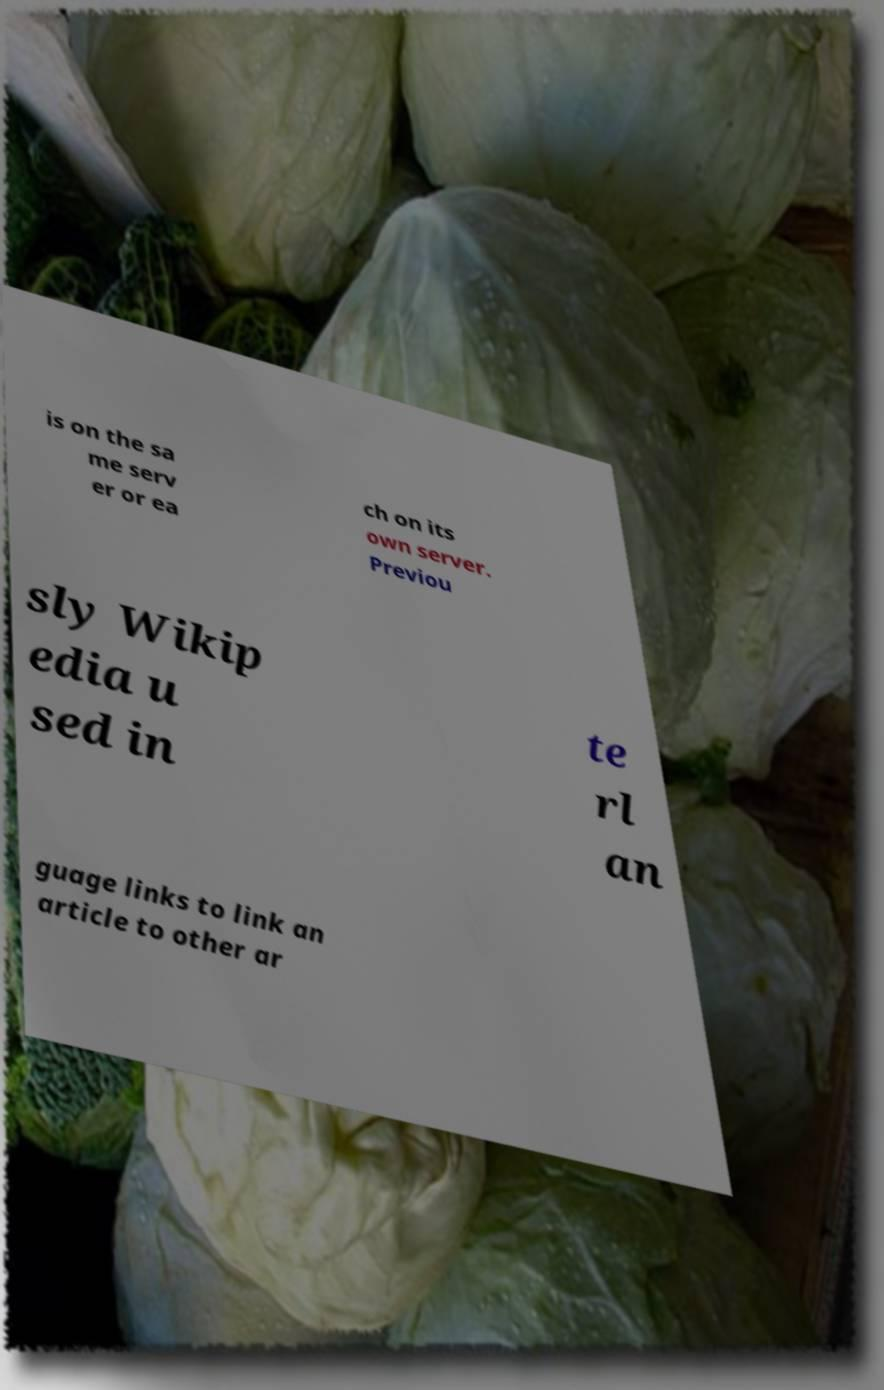Could you extract and type out the text from this image? is on the sa me serv er or ea ch on its own server. Previou sly Wikip edia u sed in te rl an guage links to link an article to other ar 